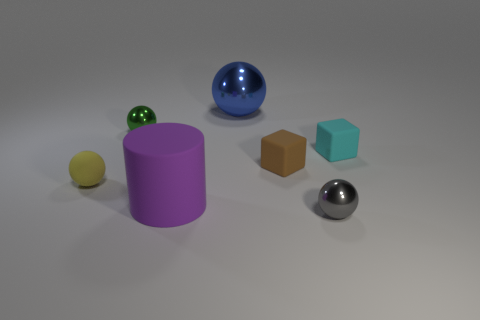How many other objects are the same color as the cylinder?
Make the answer very short. 0. Is the color of the big object that is left of the blue thing the same as the large metal thing?
Keep it short and to the point. No. There is a tiny block on the left side of the tiny gray metallic sphere; what is its material?
Provide a succinct answer. Rubber. What is the size of the matte block that is on the left side of the tiny shiny thing on the right side of the brown cube?
Provide a short and direct response. Small. How many cylinders are the same size as the yellow ball?
Your response must be concise. 0. There is a ball in front of the small yellow object; does it have the same color as the matte cylinder that is in front of the brown rubber cube?
Offer a terse response. No. There is a large blue sphere; are there any small yellow matte things behind it?
Your response must be concise. No. What is the color of the thing that is both right of the big purple matte object and in front of the rubber sphere?
Ensure brevity in your answer.  Gray. Is there a big cube of the same color as the big sphere?
Provide a short and direct response. No. Do the gray object in front of the large matte cylinder and the object on the right side of the tiny gray metal thing have the same material?
Keep it short and to the point. No. 